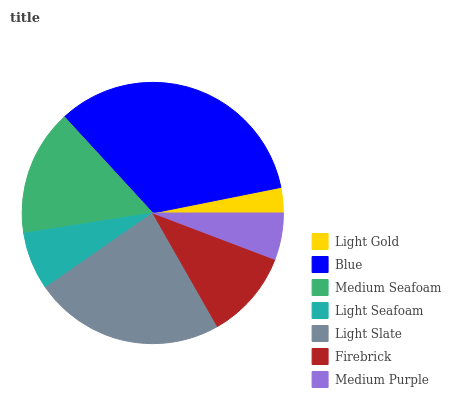Is Light Gold the minimum?
Answer yes or no. Yes. Is Blue the maximum?
Answer yes or no. Yes. Is Medium Seafoam the minimum?
Answer yes or no. No. Is Medium Seafoam the maximum?
Answer yes or no. No. Is Blue greater than Medium Seafoam?
Answer yes or no. Yes. Is Medium Seafoam less than Blue?
Answer yes or no. Yes. Is Medium Seafoam greater than Blue?
Answer yes or no. No. Is Blue less than Medium Seafoam?
Answer yes or no. No. Is Firebrick the high median?
Answer yes or no. Yes. Is Firebrick the low median?
Answer yes or no. Yes. Is Medium Purple the high median?
Answer yes or no. No. Is Medium Seafoam the low median?
Answer yes or no. No. 